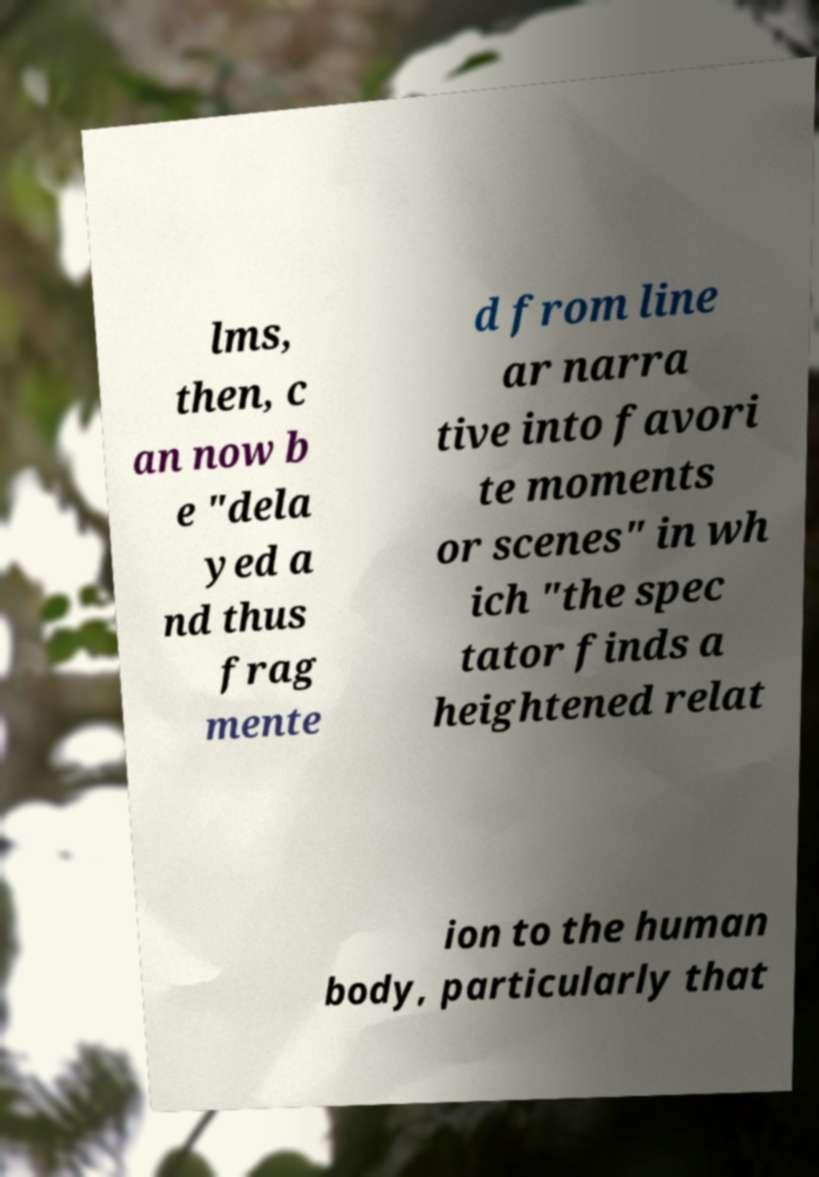Could you extract and type out the text from this image? lms, then, c an now b e "dela yed a nd thus frag mente d from line ar narra tive into favori te moments or scenes" in wh ich "the spec tator finds a heightened relat ion to the human body, particularly that 